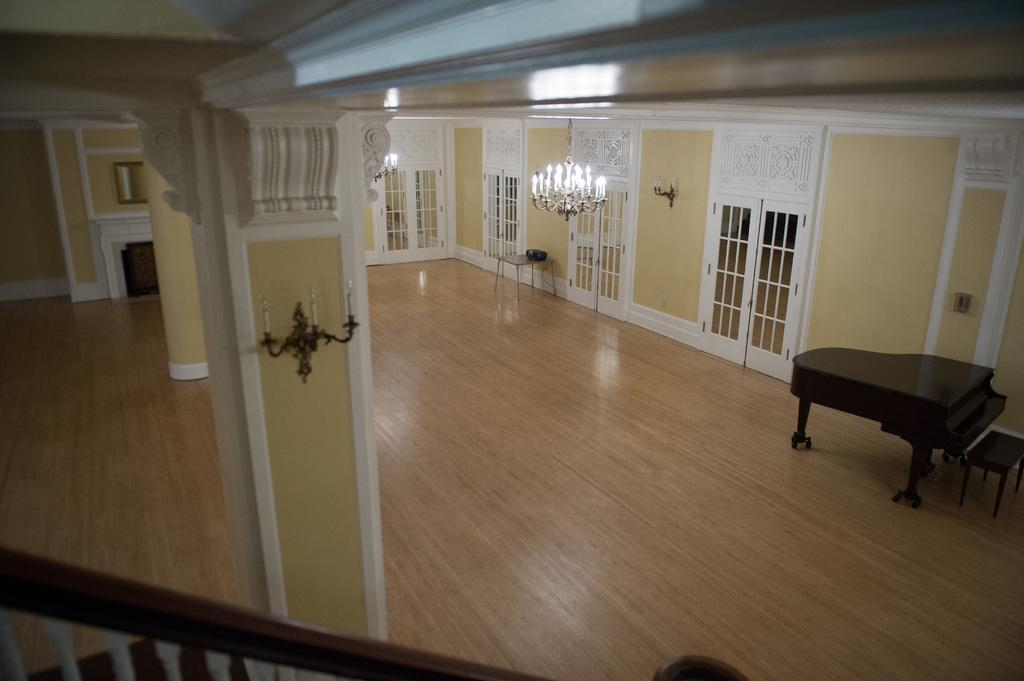What type of furniture is present in the image? There is a piano table and a chair in the image. What can be seen in the background of the image? There are designed doors and lights fitted to the roof in the background of the image. Are there any architectural features in the image? Yes, there are designer pillars in the image. How does the piano table shake in the image? The piano table does not shake in the image; it is stationary. Can you describe the breathing pattern of the chair in the image? Chairs do not have the ability to breathe, so this question cannot be answered. 